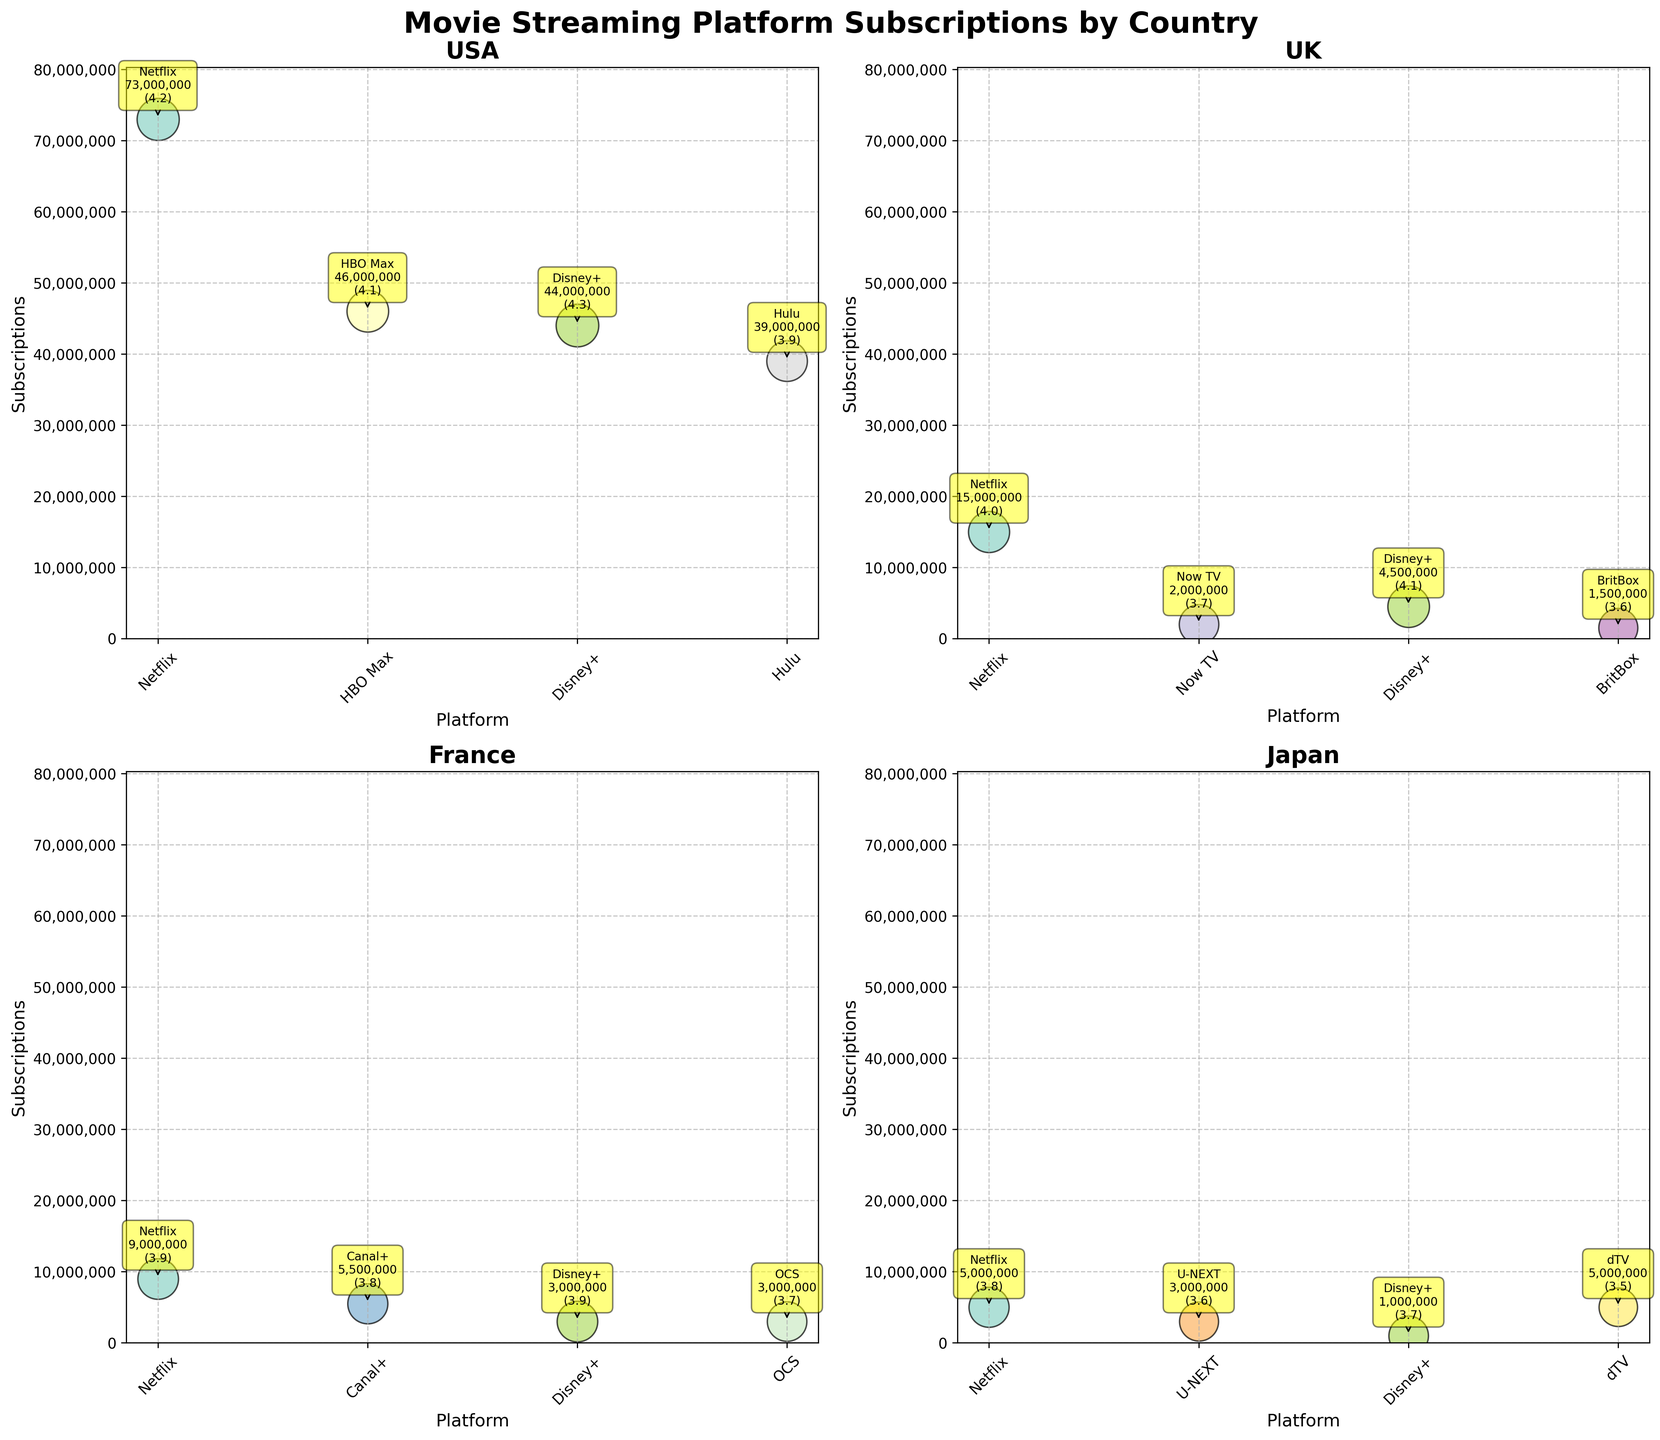How many platforms are shown for the USA? To find the number of platforms for the USA, look at the subplot titled "USA" and count the number of unique bubbles (each representing a platform).
Answer: 4 Which platform in Japan has the highest average rating? To answer this, locate the subplot for Japan and compare the sizes of the bubbles. The largest bubble represents the highest average rating.
Answer: Netflix Compare Disney+ subscriptions between the UK and USA. Which country has more, and by how much? Find the bubbles for Disney+ in both the UK and USA subplots. The USA has 44,000,000 subscriptions, and the UK has 4,500,000 subscriptions. Subtract 4,500,000 from 44,000,000.
Answer: USA, by 39,500,000 What is the title of the figure? The title is written at the top of the figure in a bold, larger font.
Answer: Movie Streaming Platform Subscriptions by Country What are the average user ratings for HBO Max and Hulu in the USA? Look at the annotations within the USA subplot. Find the bubbles labeled HBO Max and Hulu and read the average ratings from the annotations.
Answer: 4.1 for HBO Max, 3.9 for Hulu Which country has the fewest subscriptions for Disney+ and how many? Look at the Disney+ bubbles in all the countries' subplots and compare the subscriptions. Japan has the least with 1,000,000 subscriptions.
Answer: Japan, 1,000,000 Are there any platforms in France with an average rating of 3.8? If so, list them. Check the subplot for France and look for bubbles with an average rating of 3.8. There are Canal+ and OCS.
Answer: Canal+, OCS What is the total number of subscriptions for Netflix across all countries? Add the subscriptions for Netflix across USA, UK, France, and Japan: 73,000,000 + 15,000,000 + 9,000,000 + 5,000,000.
Answer: 102,000,000 Which platform in the UK has the lowest average rating and what is it? In the UK subplot, find the bubble with the smallest size. The smallest bubble belongs to BritBox with a rating of 3.6.
Answer: BritBox, 3.6 